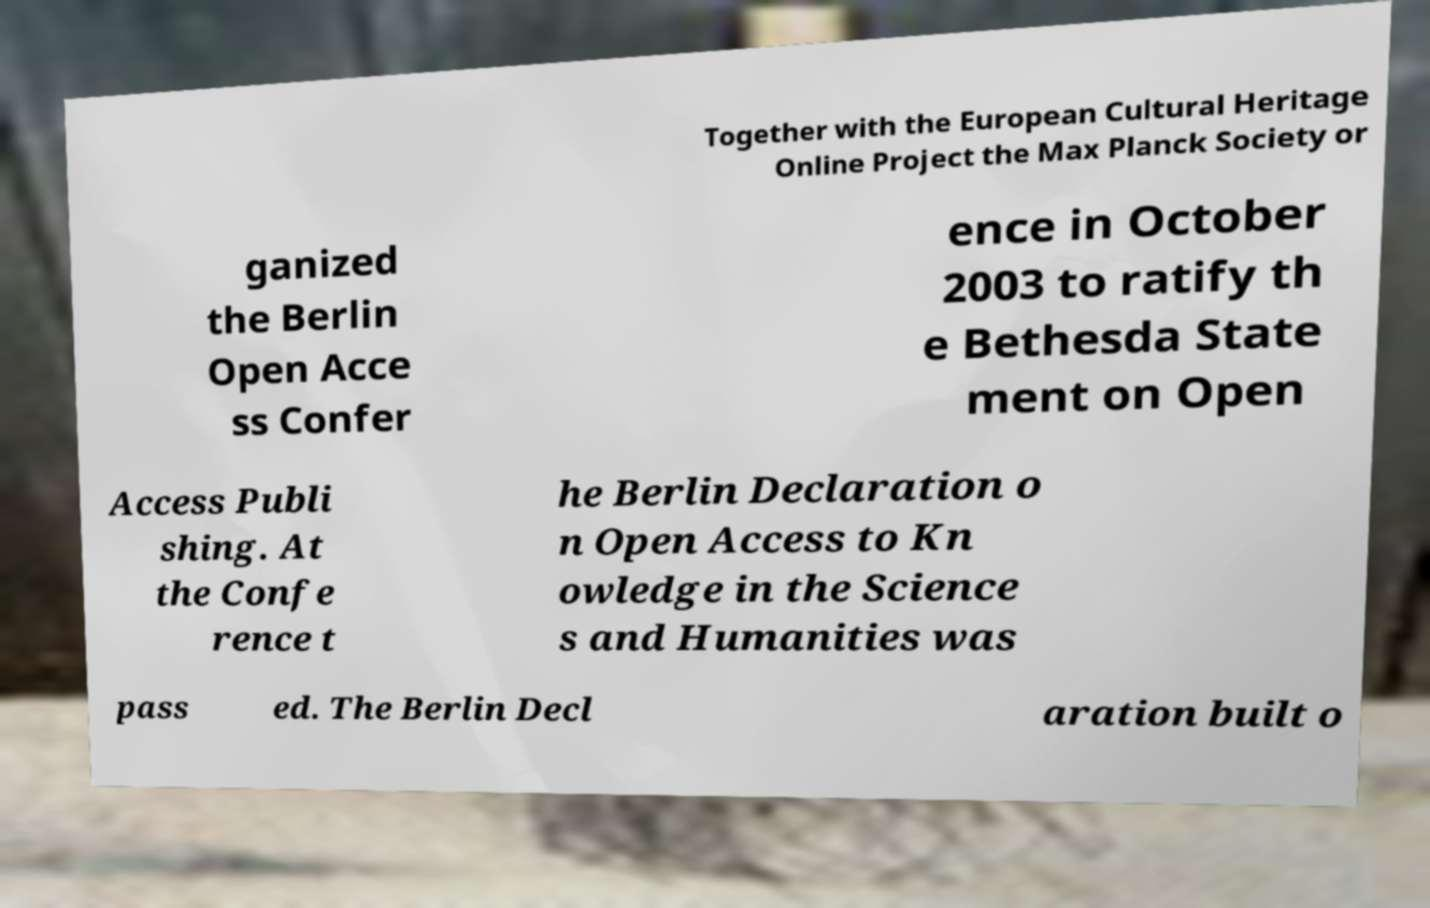What messages or text are displayed in this image? I need them in a readable, typed format. Together with the European Cultural Heritage Online Project the Max Planck Society or ganized the Berlin Open Acce ss Confer ence in October 2003 to ratify th e Bethesda State ment on Open Access Publi shing. At the Confe rence t he Berlin Declaration o n Open Access to Kn owledge in the Science s and Humanities was pass ed. The Berlin Decl aration built o 